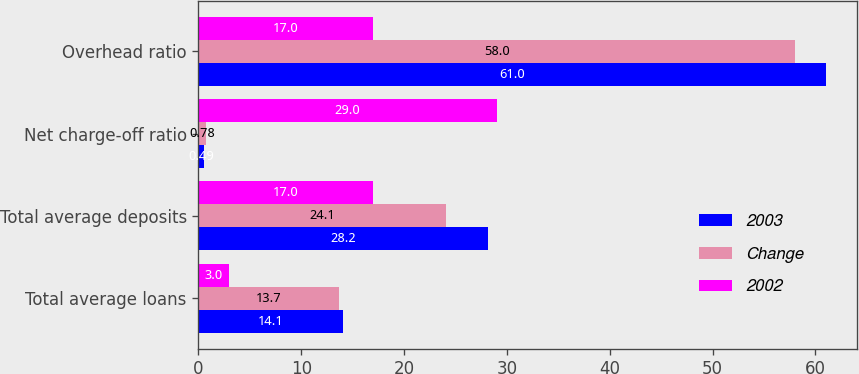Convert chart. <chart><loc_0><loc_0><loc_500><loc_500><stacked_bar_chart><ecel><fcel>Total average loans<fcel>Total average deposits<fcel>Net charge-off ratio<fcel>Overhead ratio<nl><fcel>2003<fcel>14.1<fcel>28.2<fcel>0.49<fcel>61<nl><fcel>Change<fcel>13.7<fcel>24.1<fcel>0.78<fcel>58<nl><fcel>2002<fcel>3<fcel>17<fcel>29<fcel>17<nl></chart> 